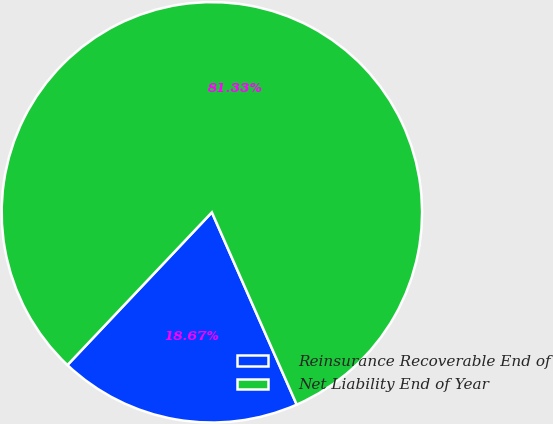Convert chart to OTSL. <chart><loc_0><loc_0><loc_500><loc_500><pie_chart><fcel>Reinsurance Recoverable End of<fcel>Net Liability End of Year<nl><fcel>18.67%<fcel>81.33%<nl></chart> 